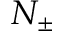Convert formula to latex. <formula><loc_0><loc_0><loc_500><loc_500>N _ { \pm }</formula> 